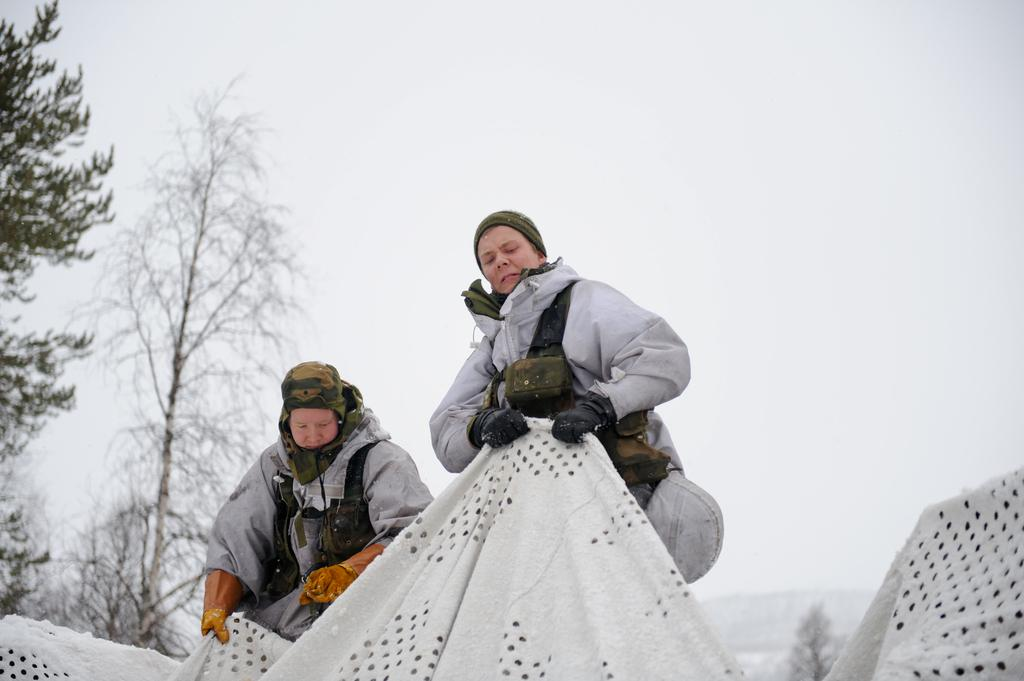How many people are in the image? There are two persons in the image. What are the persons wearing on their hands? The persons are wearing hand gloves. What are the persons holding in the image? The persons are holding the same cloth. What can be seen in the background of the image? There are trees and the sky visible in the background of the image. What type of punishment is being administered to the persons in the image? There is no indication of punishment in the image; the persons are simply holding a cloth and wearing hand gloves. What is the texture of the cloth being held by the persons in the image? The texture of the cloth cannot be determined from the image alone, as it does not provide enough detail about the material or appearance of the cloth. 